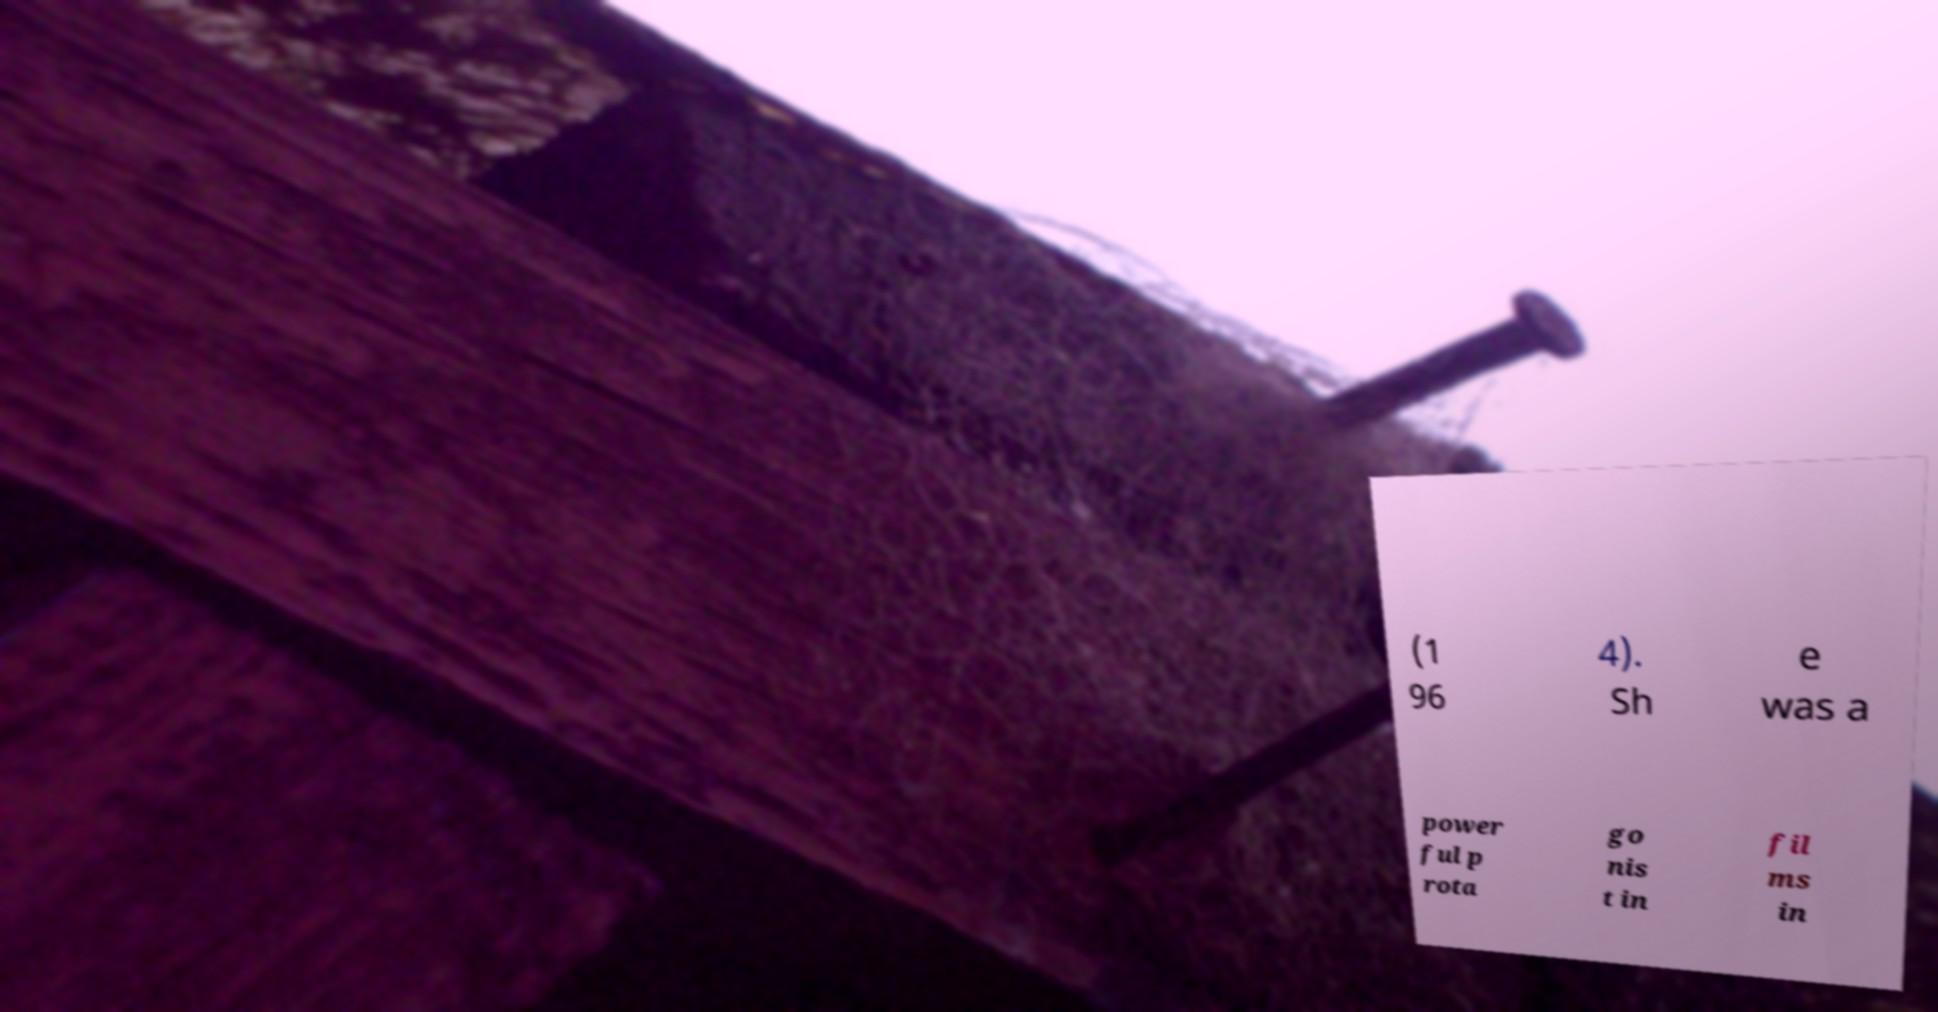Could you extract and type out the text from this image? (1 96 4). Sh e was a power ful p rota go nis t in fil ms in 